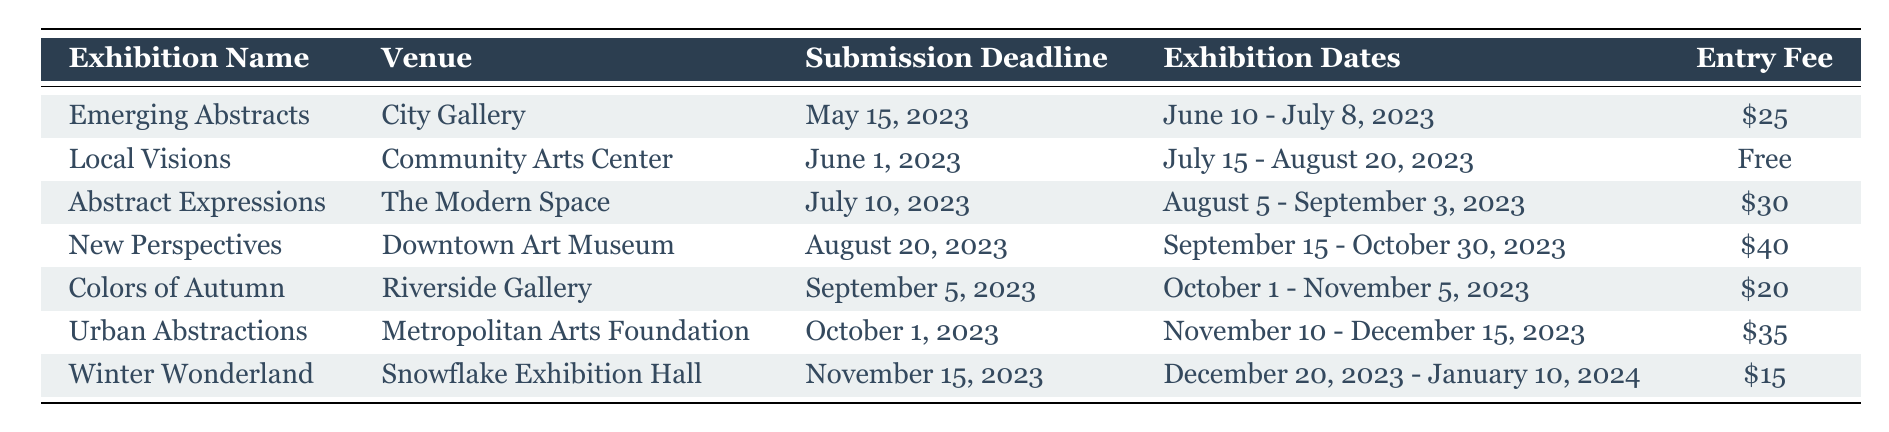What's the entry fee for the exhibition "Urban Abstractions"? The entry fee for "Urban Abstractions" is listed in the table under the "Entry Fee" column corresponding to that exhibition. Looking at the row for "Urban Abstractions", the fee is $35.
Answer: $35 What are the dates for the "Colors of Autumn" exhibition? The exhibition dates for "Colors of Autumn" are given in the table under the "Exhibition Dates" column. The corresponding row shows the dates are October 1 - November 5, 2023.
Answer: October 1 - November 5, 2023 Is there an exhibition taking place in December 2023? To determine this, I can check the "Exhibition Dates" for all entries. "Urban Abstractions" runs from November 10 to December 15, 2023, which includes December. Thus, the answer is yes.
Answer: Yes What is the average entry fee for the exhibitions listed? First, I need to add all the entry fees together: $25 + $0 (free) + $30 + $40 + $20 + $35 + $15 = $165. There are 6 paid entries; thus, the average is $165 divided by 6, which equals $27.50.
Answer: $27.50 Which venues are hosting exhibitions after September 2023? By checking the table, the exhibitions "Urban Abstractions" (Metropolitan Arts Foundation) and "Winter Wonderland" (Snowflake Exhibition Hall) are after September. "Urban Abstractions" runs from November 10 to December 15, 2023, and "Winter Wonderland" is from December 20, 2023, to January 10, 2024.
Answer: Metropolitan Arts Foundation, Snowflake Exhibition Hall How many exhibitions have entry fees of $20 or less? I can filter the "Entry Fee" column for fees of $20 or less. The exhibitions are "Colors of Autumn" ($20) and "Winter Wonderland" ($15). There are 2 exhibitions that meet this criterion.
Answer: 2 Is the submission deadline for "Abstract Expressions" before or after July 15, 2023? The submission deadline for "Abstract Expressions" is July 10, 2023, which is before July 15, 2023.
Answer: Before What is the total number of exhibitions listed in the table? Count the number of rows under the header, excluding the header itself. There are 7 exhibitions listed in total.
Answer: 7 